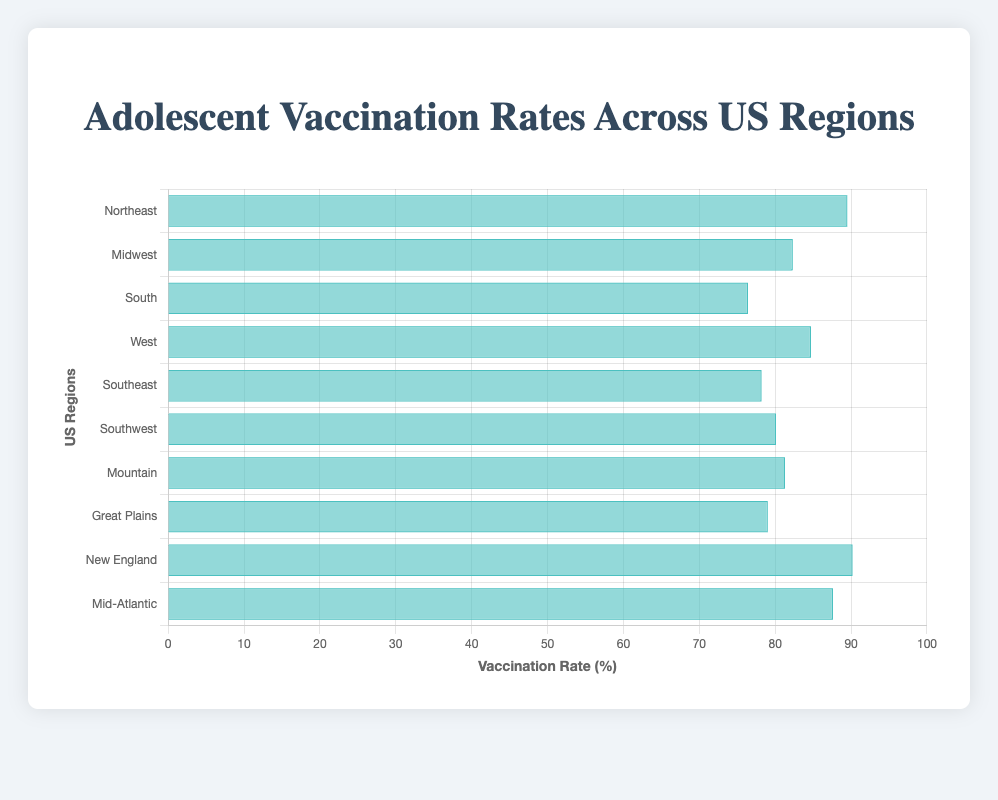Which region has the highest adolescent vaccination rate? To find the highest vaccination rate, compare the values of the vaccination rates across all regions. New England has the highest rate at 90.2%.
Answer: New England Which region has the lowest adolescent vaccination rate? To determine the lowest vaccination rate, compare the values of the vaccination rates across all regions. The South has the lowest rate at 76.4%.
Answer: South What is the difference in vaccination rates between the Northeast and the South? Find the vaccination rates for the Northeast (89.5%) and the South (76.4%), then subtract the latter from the former: 89.5% - 76.4% = 13.1%.
Answer: 13.1% What is the average vaccination rate of the Midwest, Mountain, and Great Plains regions? Find the vaccination rates for the Midwest (82.3%), Mountain (81.3%), and Great Plains (79.0%), then calculate the average: (82.3 + 81.3 + 79.0) / 3 = 80.87%.
Answer: 80.87% How many regions have a vaccination rate above 80%? Identify regions with vaccination rates above 80%: Northeast, Midwest, West, Southwest, Mountain, New England, Mid-Atlantic. Count these regions: 7 regions.
Answer: 7 Which regions have vaccination rates within 5% of each other? Compare the vaccination rates to find those within a 5% range: 
- Midwest (82.3%) and Southwest (80.1%) differ by 2.2%.
- Midwest (82.3%) and Mountain (81.3%) differ by 1%.
- West (84.7%) and Midwest (82.3%) differ by 2.4%.
- Mountain (81.3%) and Great Plains (79.0%) differ by 2.3%.
- Southwest (80.1%) and Mountain (81.3%) differ by 1.2%.
Thus, five pairs fit within a 5% range.
Answer: Midwest-Southwest, Midwest-Mountain, West-Midwest, Mountain-Great Plains, Southwest-Mountain Do any regions have identical states listed? Review the states listed for each region to identify any overlap. The West and Mountain regions both list Colorado.
Answer: Yes, West and Mountain What is the total combined number of regions with vaccination rates above and below 80%? Count regions above 80%: 7 (Northeast, Midwest, West, Southwest, Mountain, New England, Mid-Atlantic). Count regions below 80%: 3 (South, Southeast, Great Plains). Sum these counts: 7 + 3 = 10.
Answer: 10 Which region has a higher vaccination rate, Southeast or Southwest? Compare the vaccination rates: Southeast (78.2%) and Southwest (80.1%). The Southwest has a higher rate.
Answer: Southwest 